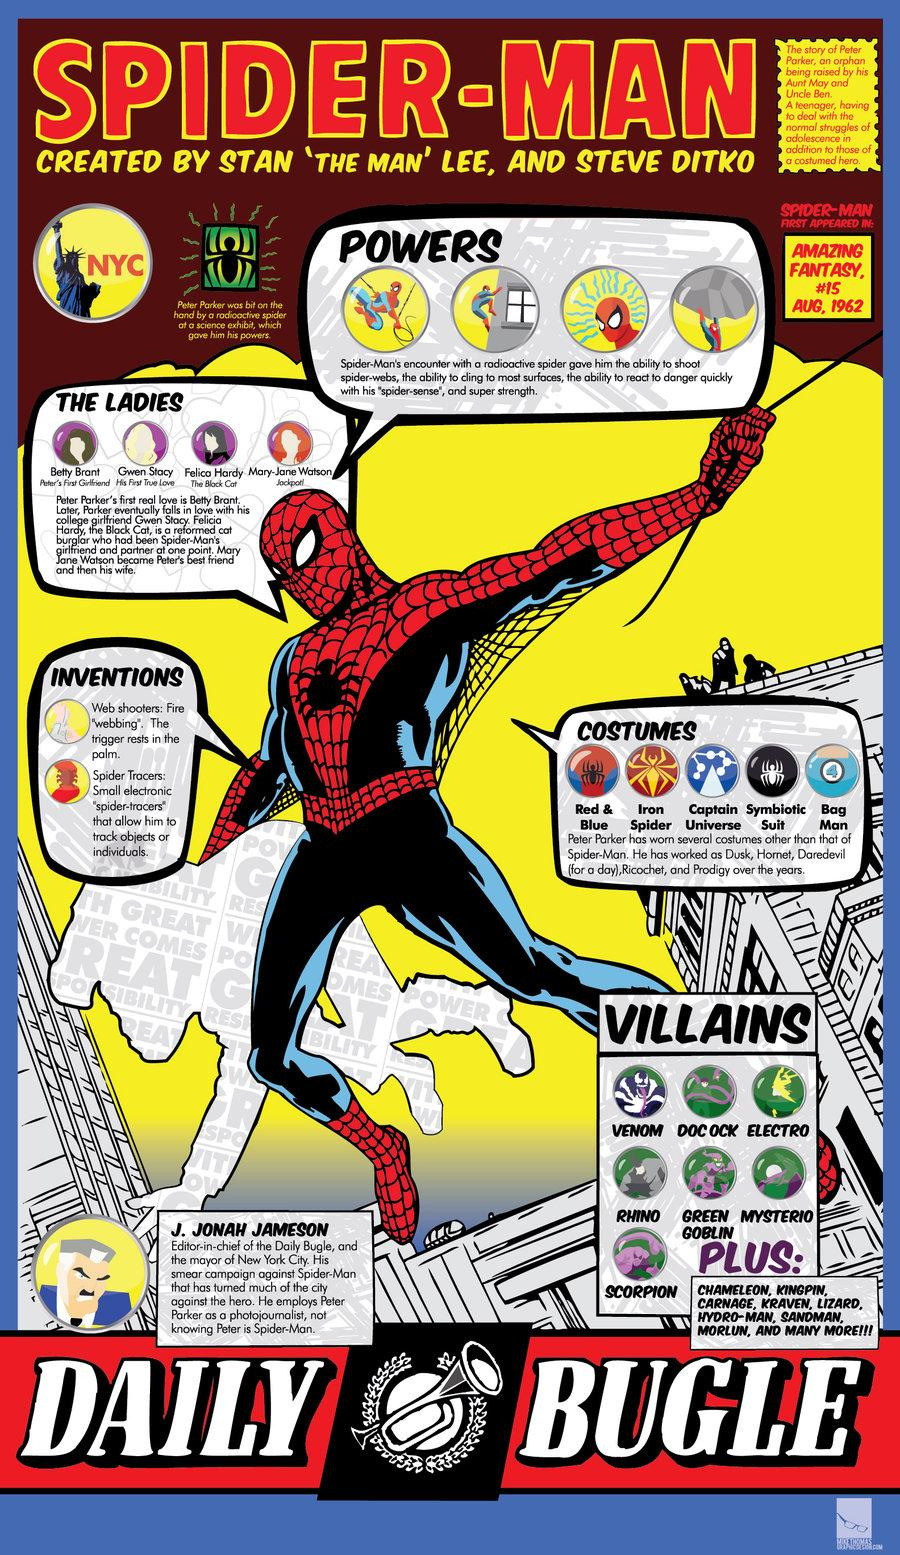List a handful of essential elements in this visual. The box titled 'villains' contains 7 illustrated villains. The spider on Spider-Man's suit is black, not red, blue, or any other color. The release date of Spider-Man was August 15, 1962. 